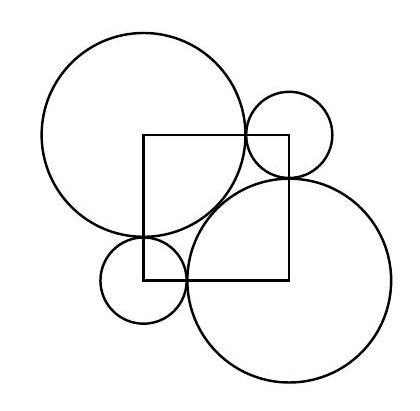The diagram shows two identical large circles and two identical smaller circles whose centres are at the corners of a square. The two large circles are touching, and they each touch the two smaller circles. The radius of the small circles is $1 \mathrm{~cm}$. What is the radius of a large circle in centimetres? To determine the radius of the larger circles, we need to use the Pythagorean theorem. The center of the large circle, the touching point of the two smaller circles, and the center of one of the smaller circles form a right triangle. The hypotenuse of this right triangle is the sum of the radii of the large and small circles, while one leg is the diameter of the smaller circle (2 cm), and the other is the difference between the large and small radii. By applying the theorem, we find that the radius of the large circle is indeed '$1+\sqrt{2}$' centimeters. 